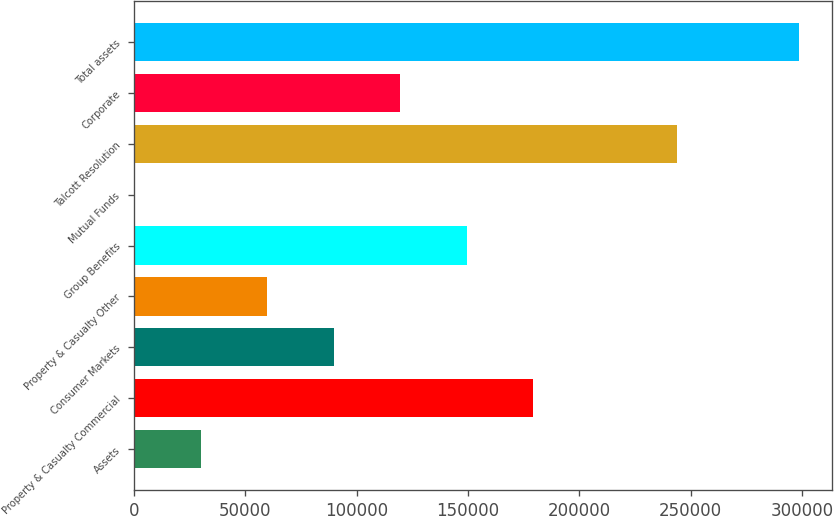Convert chart. <chart><loc_0><loc_0><loc_500><loc_500><bar_chart><fcel>Assets<fcel>Property & Casualty Commercial<fcel>Consumer Markets<fcel>Property & Casualty Other<fcel>Group Benefits<fcel>Mutual Funds<fcel>Talcott Resolution<fcel>Corporate<fcel>Total assets<nl><fcel>30143.8<fcel>179238<fcel>89781.4<fcel>59962.6<fcel>149419<fcel>325<fcel>243836<fcel>119600<fcel>298513<nl></chart> 